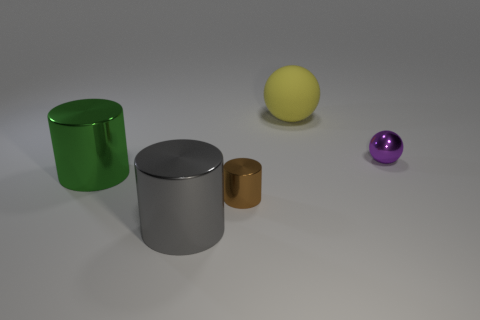Is there a purple shiny ball behind the tiny object to the left of the thing that is right of the large matte thing?
Keep it short and to the point. Yes. There is a big shiny thing on the left side of the big gray cylinder; is its shape the same as the purple object right of the big matte thing?
Give a very brief answer. No. What is the color of the ball that is the same material as the big green cylinder?
Provide a succinct answer. Purple. Are there fewer big rubber balls that are to the left of the small sphere than large matte balls?
Your response must be concise. No. There is a object that is behind the sphere in front of the rubber object that is behind the tiny ball; how big is it?
Offer a terse response. Large. Does the big cylinder that is left of the gray metallic cylinder have the same material as the yellow thing?
Your answer should be compact. No. What number of objects are either small purple spheres or brown objects?
Give a very brief answer. 2. What is the size of the brown shiny object that is the same shape as the gray thing?
Provide a short and direct response. Small. What number of other things are the same color as the tiny metal cylinder?
Offer a terse response. 0. What number of cylinders are either yellow things or purple objects?
Offer a terse response. 0. 